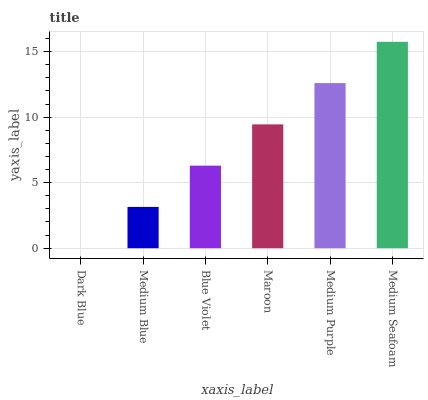Is Dark Blue the minimum?
Answer yes or no. Yes. Is Medium Seafoam the maximum?
Answer yes or no. Yes. Is Medium Blue the minimum?
Answer yes or no. No. Is Medium Blue the maximum?
Answer yes or no. No. Is Medium Blue greater than Dark Blue?
Answer yes or no. Yes. Is Dark Blue less than Medium Blue?
Answer yes or no. Yes. Is Dark Blue greater than Medium Blue?
Answer yes or no. No. Is Medium Blue less than Dark Blue?
Answer yes or no. No. Is Maroon the high median?
Answer yes or no. Yes. Is Blue Violet the low median?
Answer yes or no. Yes. Is Medium Blue the high median?
Answer yes or no. No. Is Medium Purple the low median?
Answer yes or no. No. 